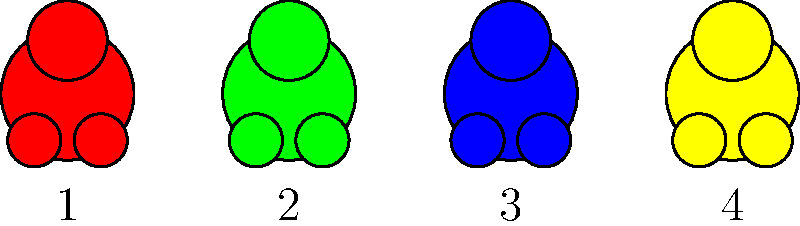As a pediatric dentist, you're studying the arrangement of different-colored gummy bears to understand children's candy preferences. Consider a set of 4 gummy bears with distinct colors (red, green, blue, yellow) as shown in the image. How many unique permutations (arrangements) of these gummy bears are possible? Additionally, what is the order of the permutation group for this set? To solve this problem, we'll follow these steps:

1) First, let's understand what permutations are. Permutations are different arrangements of a set of objects where order matters.

2) For a set of $n$ distinct objects, the number of permutations is given by $n!$ (n factorial).

3) In this case, we have 4 distinct gummy bears (each with a different color), so $n = 4$.

4) Therefore, the number of permutations is $4! = 4 \times 3 \times 2 \times 1 = 24$.

5) Each of these 24 permutations represents a unique arrangement of the 4 gummy bears.

6) The permutation group of a set is the group of all permutations of that set. The order of a group is the number of elements in the group.

7) Since we have 24 unique permutations, the order of the permutation group is also 24.

From a dental perspective, this concept could be used to understand how many different ways children might approach eating a set of candies, which could influence patterns of sugar exposure to different teeth.
Answer: 24 permutations; order of permutation group is 24 